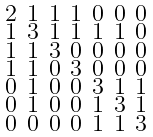<formula> <loc_0><loc_0><loc_500><loc_500>\begin{smallmatrix} 2 & 1 & 1 & 1 & 0 & 0 & 0 \\ 1 & 3 & 1 & 1 & 1 & 1 & 0 \\ 1 & 1 & 3 & 0 & 0 & 0 & 0 \\ 1 & 1 & 0 & 3 & 0 & 0 & 0 \\ 0 & 1 & 0 & 0 & 3 & 1 & 1 \\ 0 & 1 & 0 & 0 & 1 & 3 & 1 \\ 0 & 0 & 0 & 0 & 1 & 1 & 3 \end{smallmatrix}</formula> 